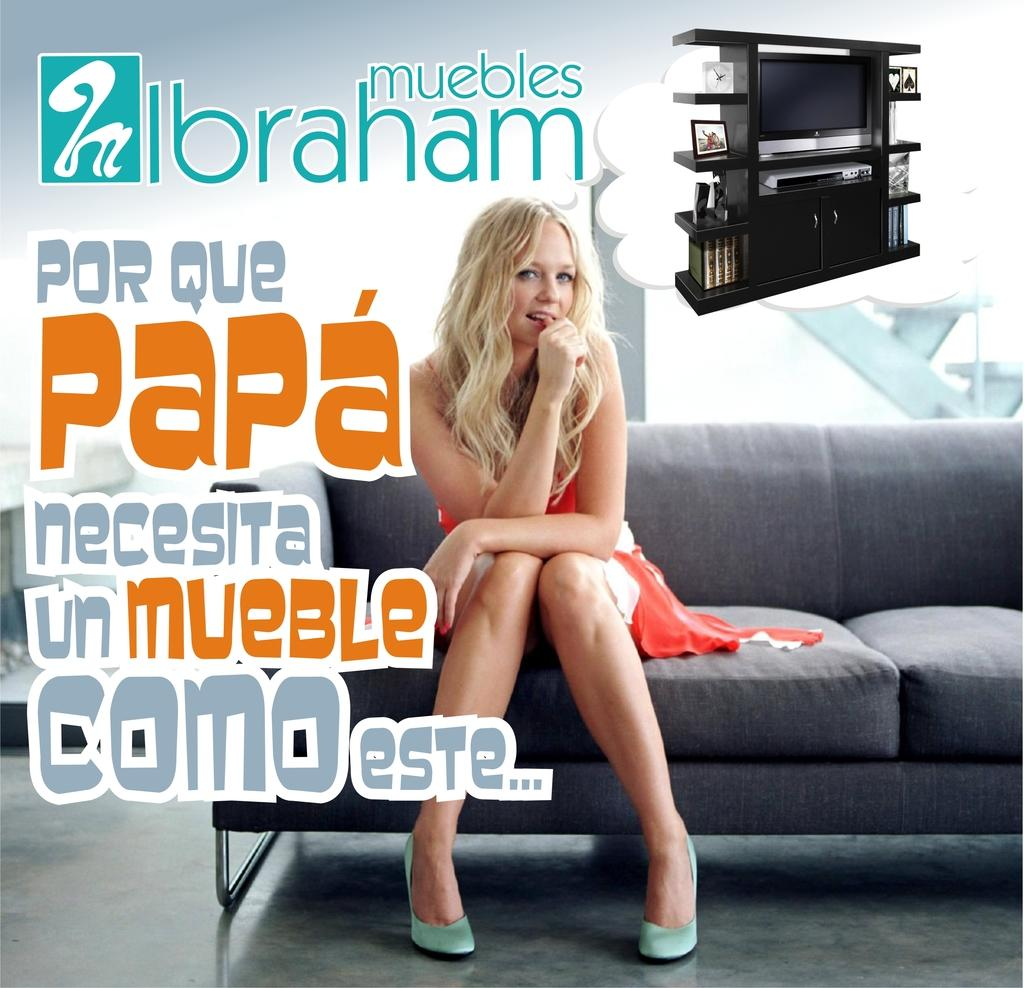<image>
Give a short and clear explanation of the subsequent image. A blonde young woman is sitting on a couch with the text saying POR QUE PAPA necesita unmueble comoeste... 